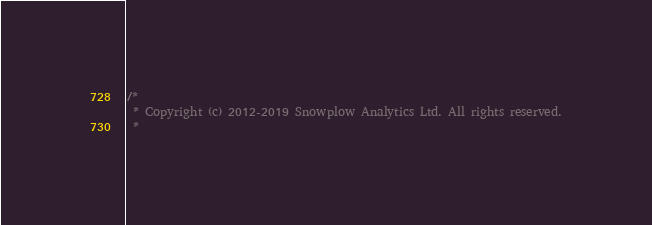Convert code to text. <code><loc_0><loc_0><loc_500><loc_500><_Scala_>/*
 * Copyright (c) 2012-2019 Snowplow Analytics Ltd. All rights reserved.
 *</code> 